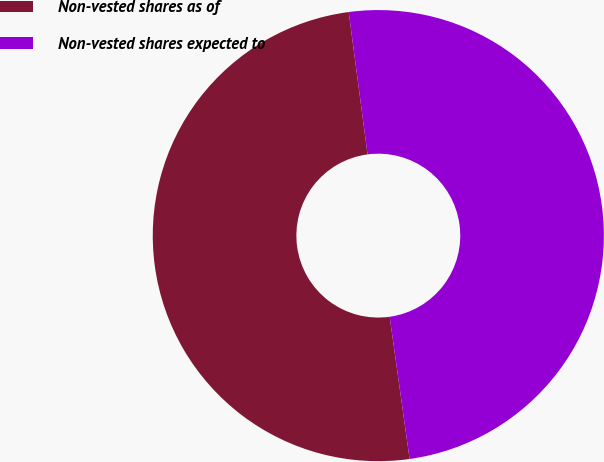Convert chart to OTSL. <chart><loc_0><loc_0><loc_500><loc_500><pie_chart><fcel>Non-vested shares as of<fcel>Non-vested shares expected to<nl><fcel>50.12%<fcel>49.88%<nl></chart> 